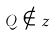<formula> <loc_0><loc_0><loc_500><loc_500>Q \notin z</formula> 